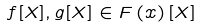Convert formula to latex. <formula><loc_0><loc_0><loc_500><loc_500>f [ X ] , g [ X ] \in F \left ( x \right ) [ X ]</formula> 